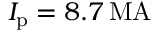Convert formula to latex. <formula><loc_0><loc_0><loc_500><loc_500>I _ { p } = 8 . 7 \, M A</formula> 